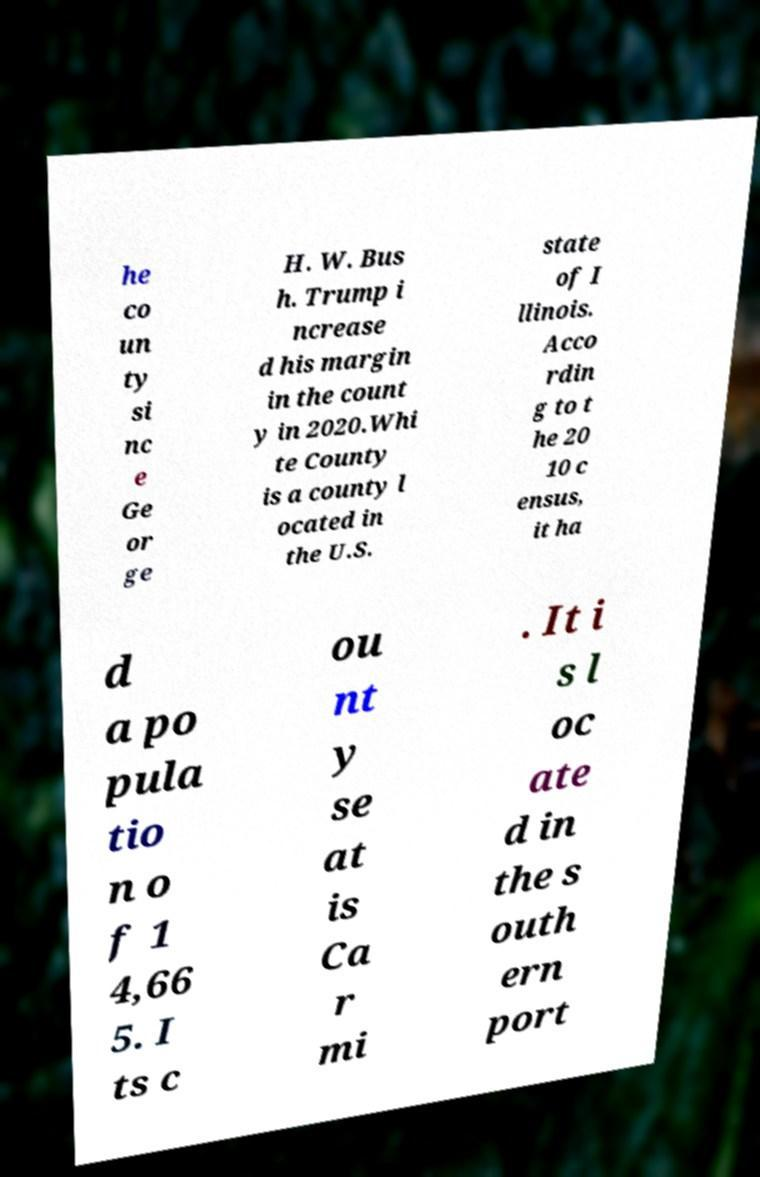There's text embedded in this image that I need extracted. Can you transcribe it verbatim? he co un ty si nc e Ge or ge H. W. Bus h. Trump i ncrease d his margin in the count y in 2020.Whi te County is a county l ocated in the U.S. state of I llinois. Acco rdin g to t he 20 10 c ensus, it ha d a po pula tio n o f 1 4,66 5. I ts c ou nt y se at is Ca r mi . It i s l oc ate d in the s outh ern port 